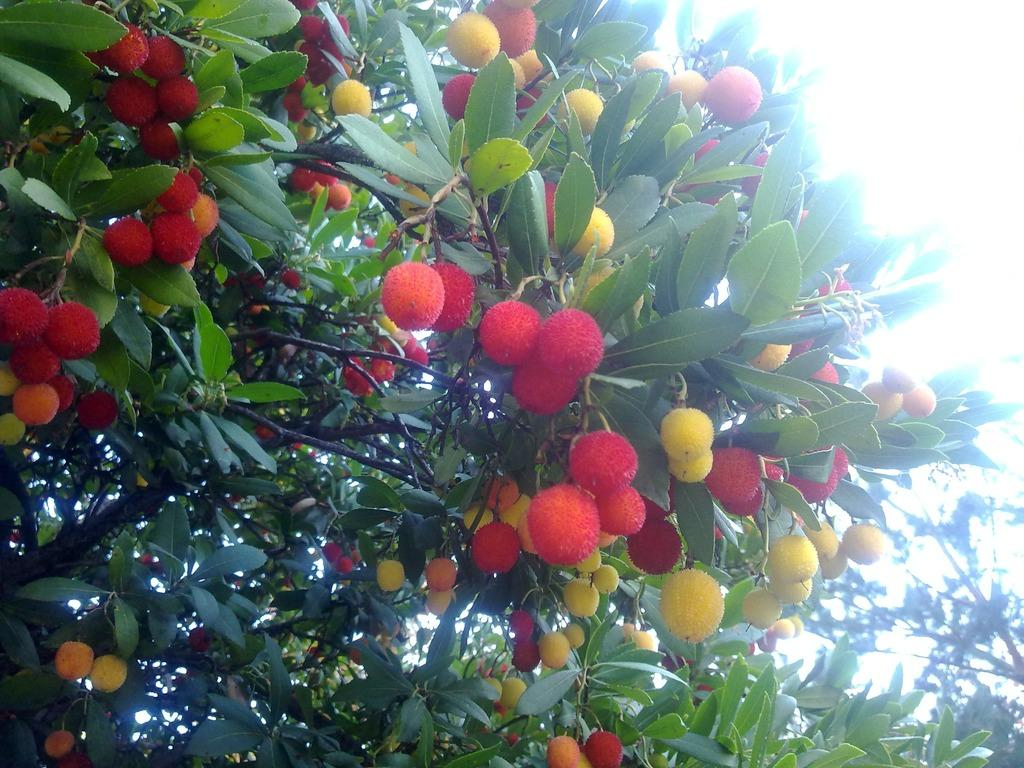What type of vegetation can be seen in the image? There are trees in the image. What is special about these trees? The trees have many fruits. What type of cushion is being used by the actor in the image? There is no actor or cushion present in the image; it only features trees with fruits. 